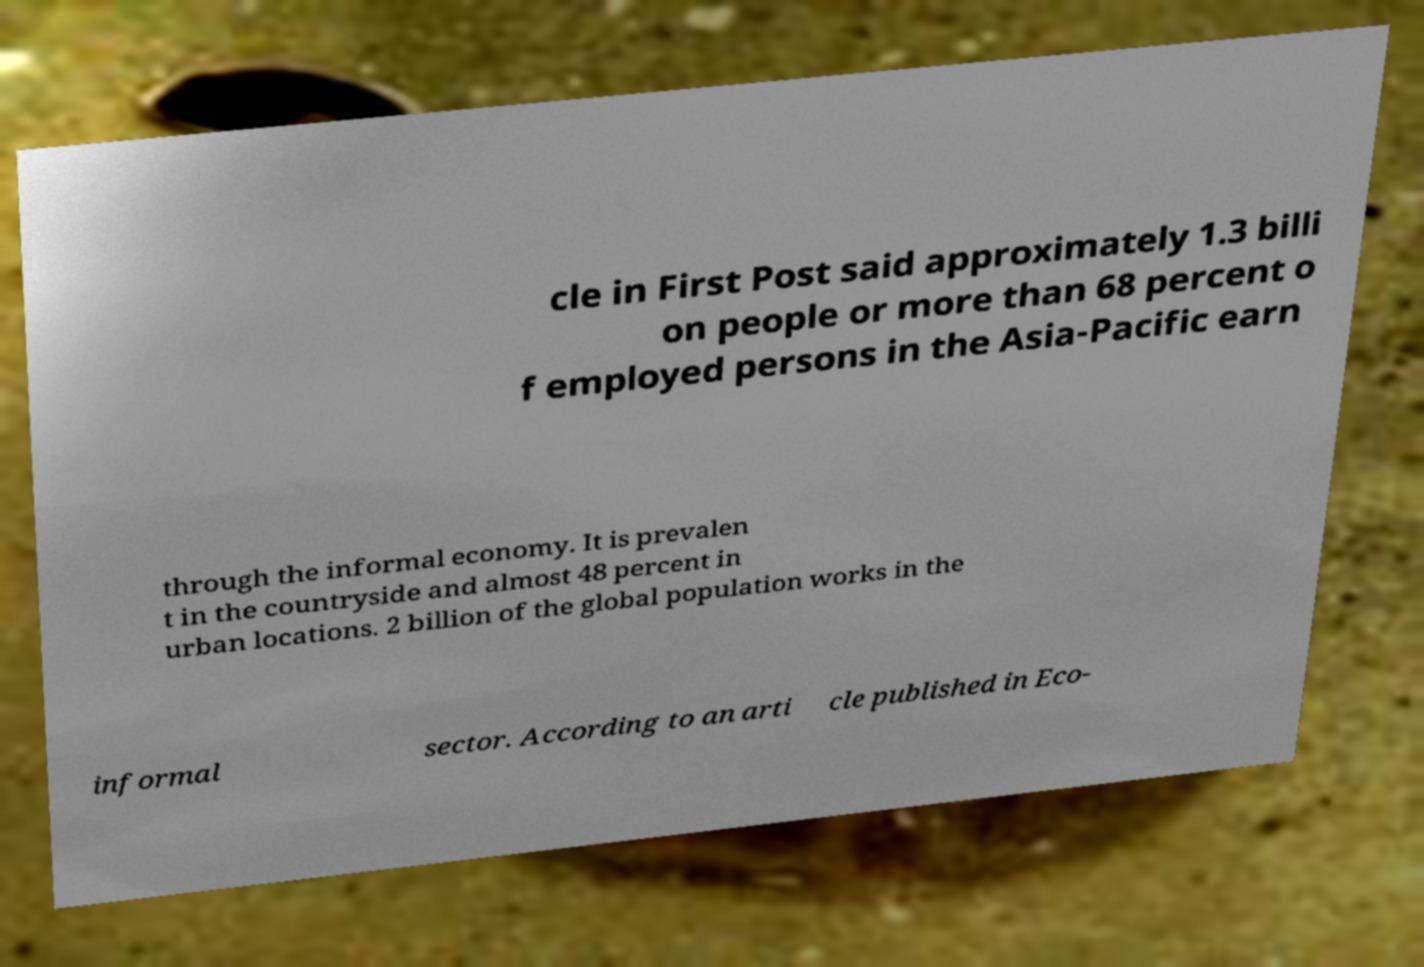Can you accurately transcribe the text from the provided image for me? cle in First Post said approximately 1.3 billi on people or more than 68 percent o f employed persons in the Asia-Pacific earn through the informal economy. It is prevalen t in the countryside and almost 48 percent in urban locations. 2 billion of the global population works in the informal sector. According to an arti cle published in Eco- 